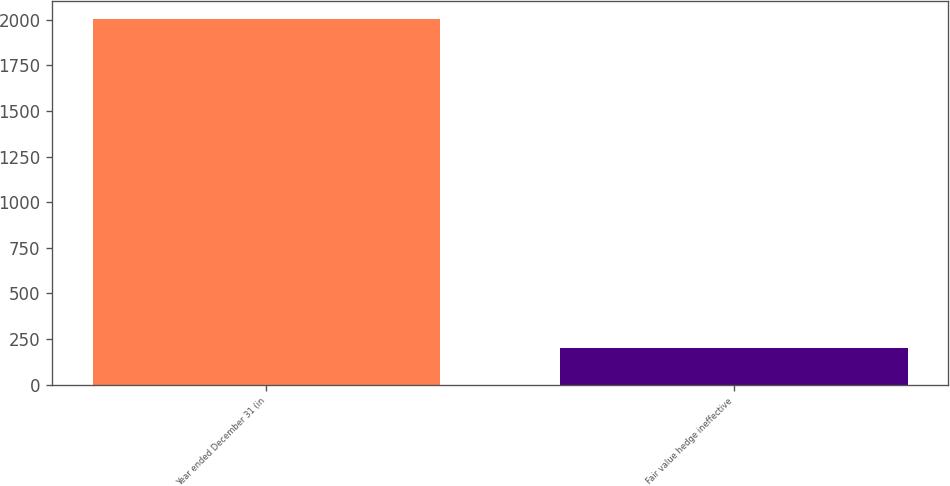Convert chart. <chart><loc_0><loc_0><loc_500><loc_500><bar_chart><fcel>Year ended December 31 (in<fcel>Fair value hedge ineffective<nl><fcel>2004<fcel>199<nl></chart> 